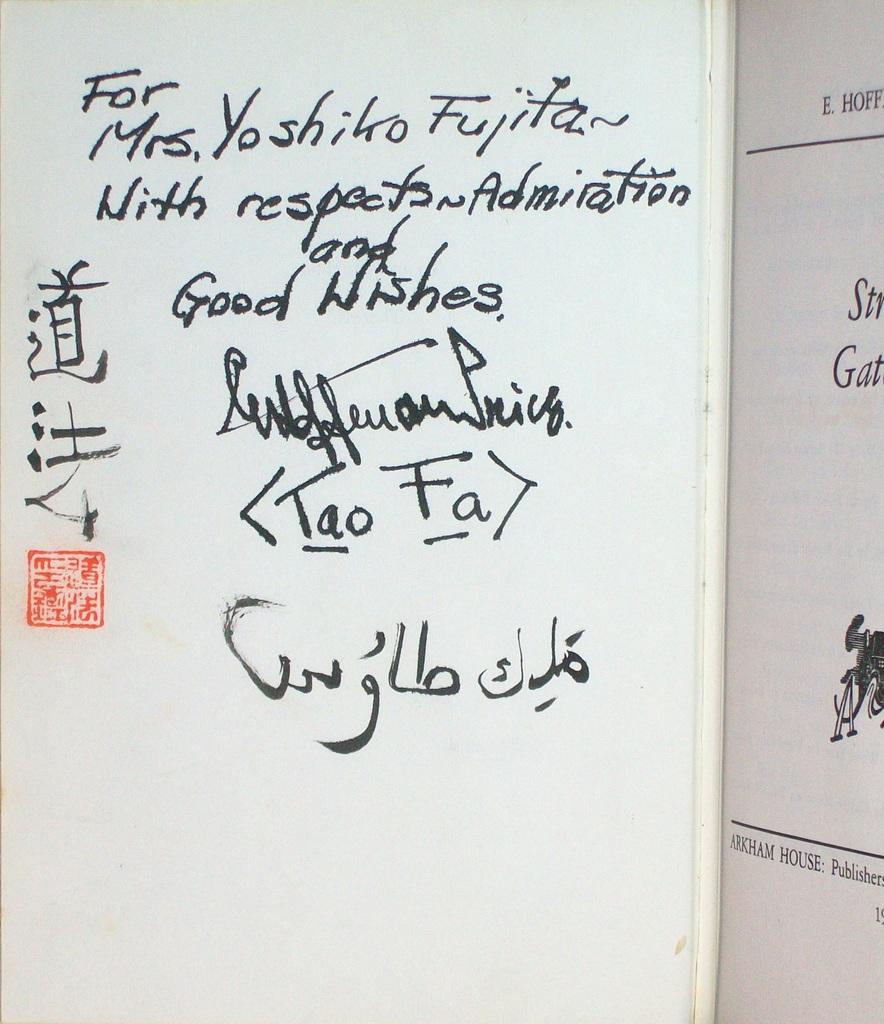What kind of wishes is this written with?
Your response must be concise. Good. 